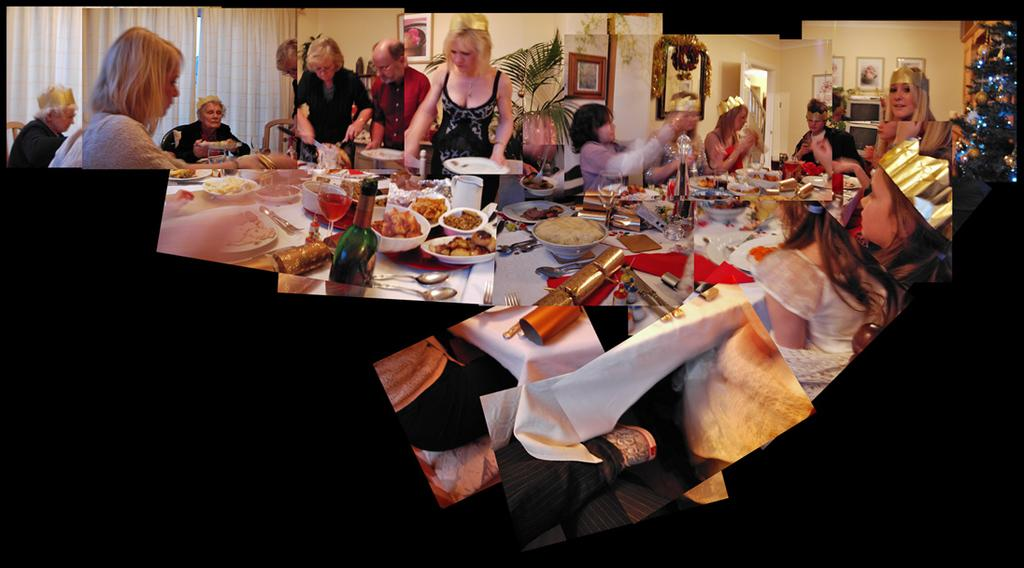How many people are in the image? There is a group of people in the image. What are some of the people in the image doing? Some people are sitting on chairs, while others are standing. What is present in the image besides the people? There is a table in the image. What can be found on the table? There are objects on the table. What type of nail is being used by the person in the image? There is no nail or person using a nail present in the image. Can you tell me how many donkeys are in the image? There are no donkeys present in the image. 